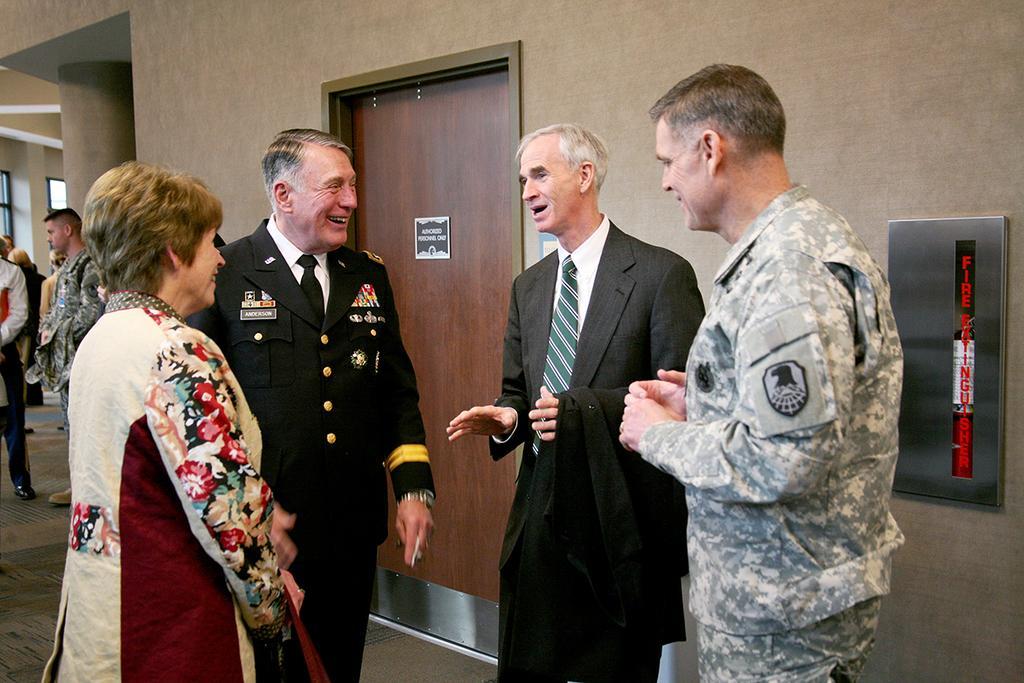Please provide a concise description of this image. In this image I can see two persons wearing uniforms, a woman wearing red and cream colored dress and a man wearing shirt, tie and blazer are standing on the ground. In the background I can see the wall, the brown colored door, few persons standing and a pillar. 